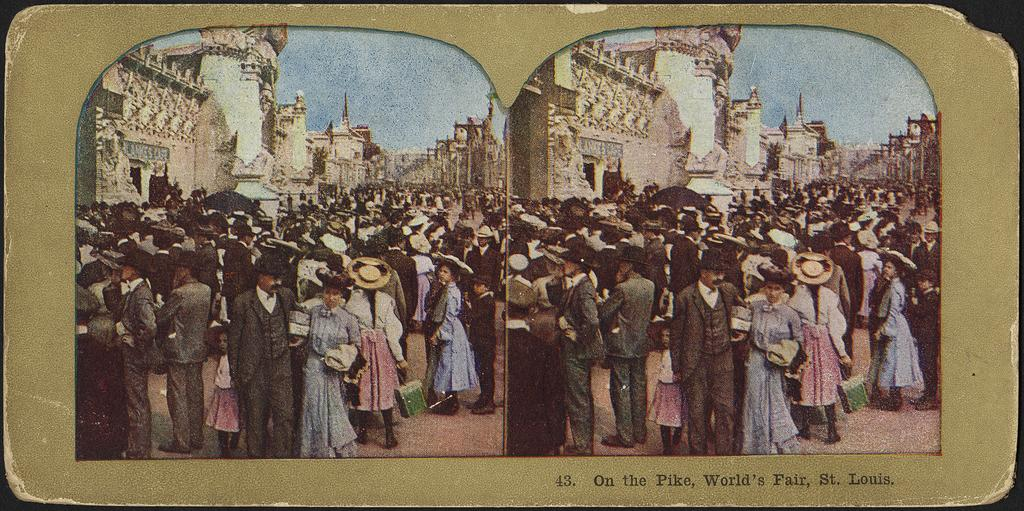Provide a one-sentence caption for the provided image. Vintage postcard on the Pike at the World's Fair in St. Louis. 